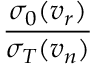<formula> <loc_0><loc_0><loc_500><loc_500>\frac { \sigma _ { 0 } ( v _ { r } ) } { \sigma _ { T } ( v _ { n } ) }</formula> 